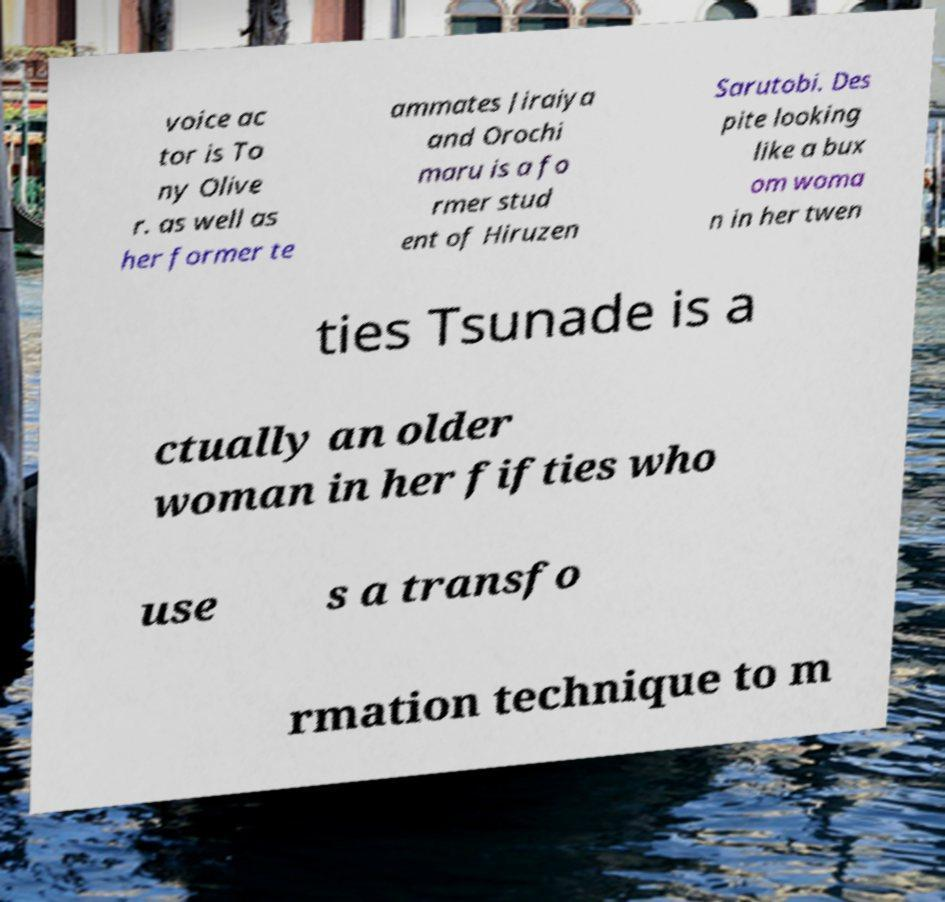Can you accurately transcribe the text from the provided image for me? voice ac tor is To ny Olive r. as well as her former te ammates Jiraiya and Orochi maru is a fo rmer stud ent of Hiruzen Sarutobi. Des pite looking like a bux om woma n in her twen ties Tsunade is a ctually an older woman in her fifties who use s a transfo rmation technique to m 